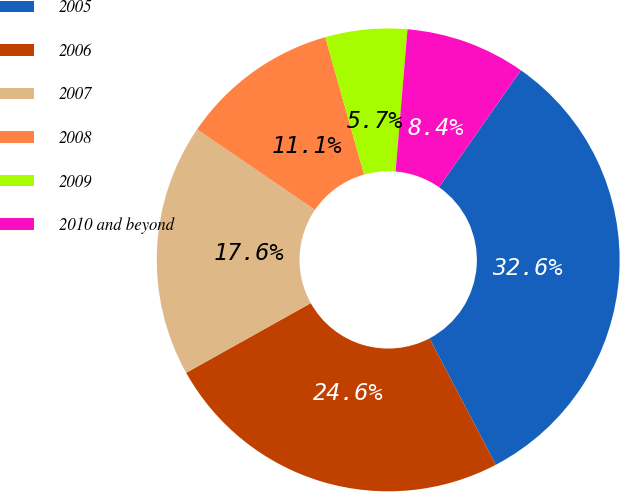<chart> <loc_0><loc_0><loc_500><loc_500><pie_chart><fcel>2005<fcel>2006<fcel>2007<fcel>2008<fcel>2009<fcel>2010 and beyond<nl><fcel>32.58%<fcel>24.59%<fcel>17.65%<fcel>11.08%<fcel>5.71%<fcel>8.39%<nl></chart> 